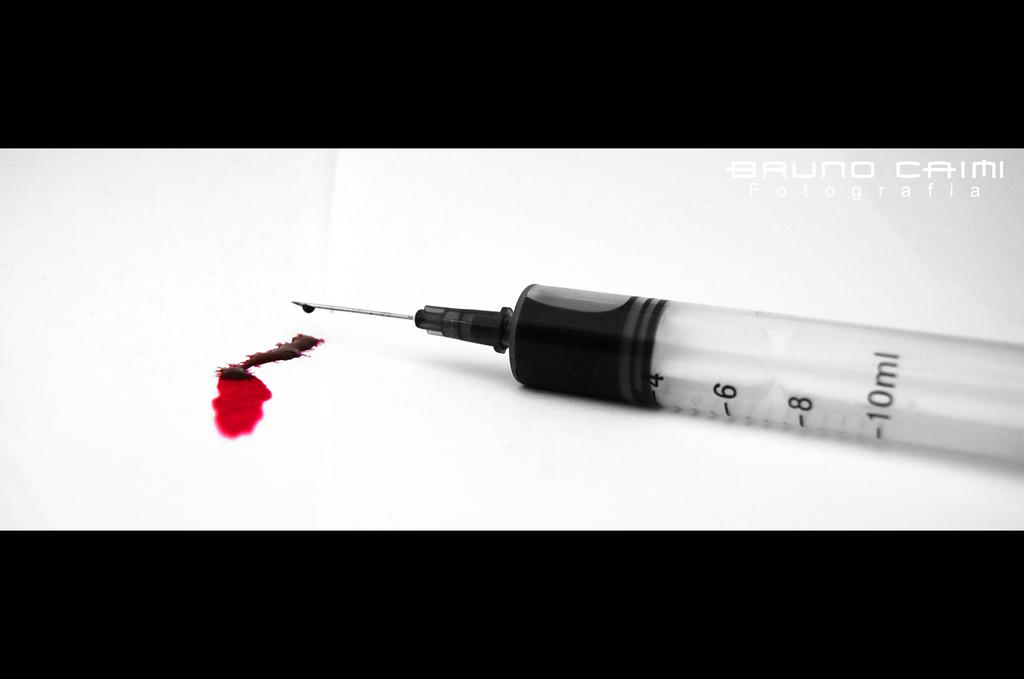What medical instrument is present in the image? There is a syringe in the image. What substance can be seen in the image? Blood is visible in the image. What color is the background of the image? The background of the image is white. What colors are used for the top and bottom of the image? The top and bottom of the image are black. How many sheep are visible in the image? There are no sheep present in the image. What type of horse can be seen grazing in the background of the image? There is no horse present in the image; the background is white. 